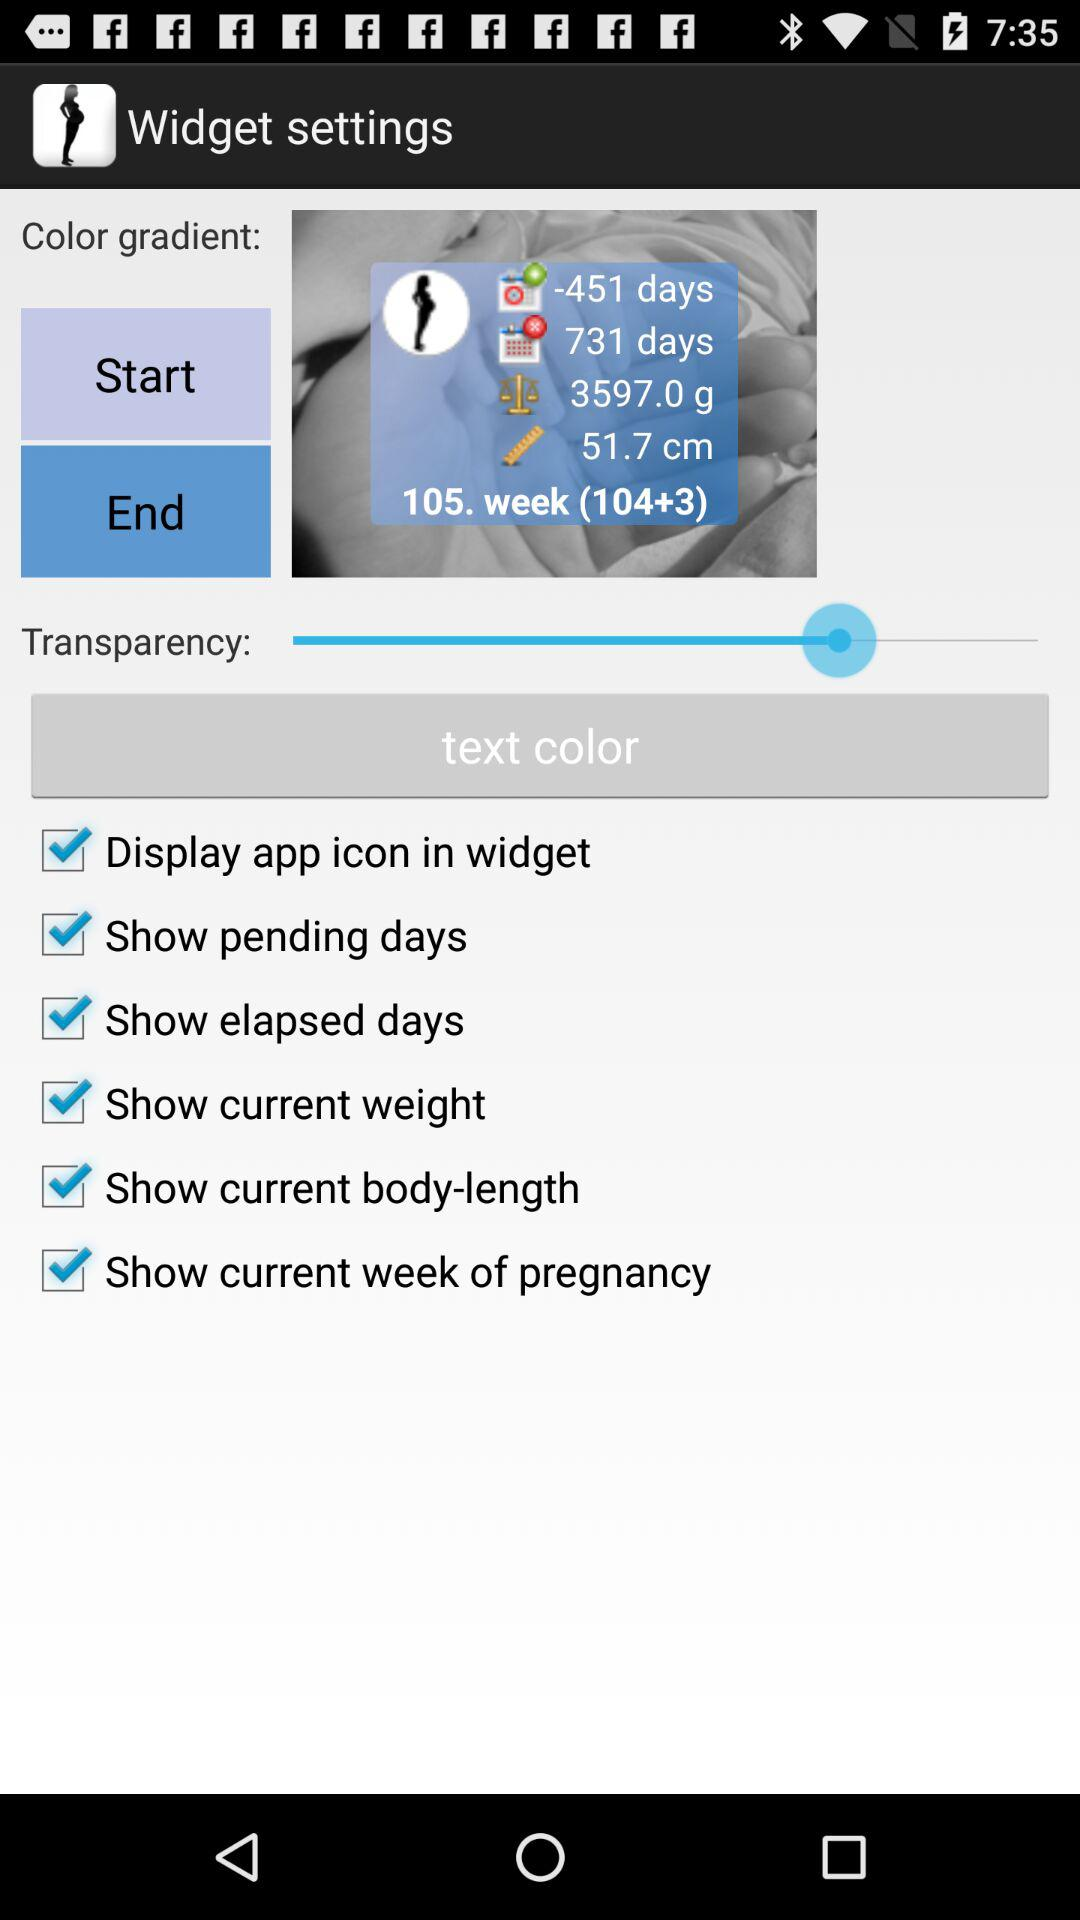What is the status of the "Display app icon in widget"? The status is "on". 